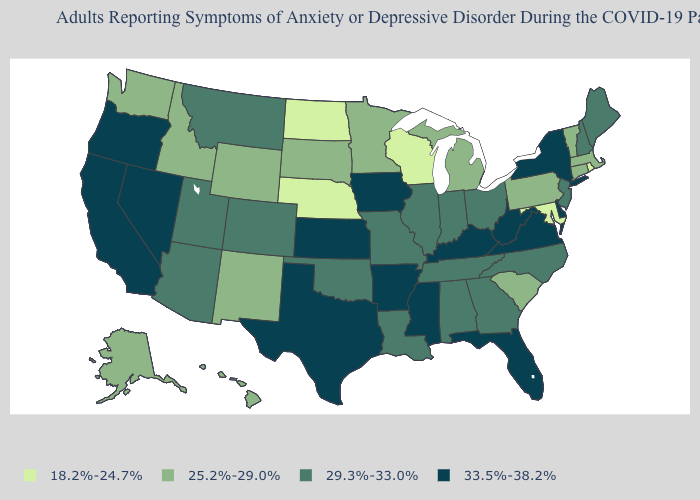What is the lowest value in the USA?
Quick response, please. 18.2%-24.7%. What is the lowest value in the West?
Be succinct. 25.2%-29.0%. What is the value of Rhode Island?
Write a very short answer. 18.2%-24.7%. What is the value of Massachusetts?
Answer briefly. 25.2%-29.0%. Does Ohio have the highest value in the USA?
Write a very short answer. No. Name the states that have a value in the range 29.3%-33.0%?
Concise answer only. Alabama, Arizona, Colorado, Georgia, Illinois, Indiana, Louisiana, Maine, Missouri, Montana, New Hampshire, New Jersey, North Carolina, Ohio, Oklahoma, Tennessee, Utah. Name the states that have a value in the range 29.3%-33.0%?
Keep it brief. Alabama, Arizona, Colorado, Georgia, Illinois, Indiana, Louisiana, Maine, Missouri, Montana, New Hampshire, New Jersey, North Carolina, Ohio, Oklahoma, Tennessee, Utah. What is the value of Kansas?
Keep it brief. 33.5%-38.2%. Among the states that border Oregon , which have the lowest value?
Be succinct. Idaho, Washington. Name the states that have a value in the range 33.5%-38.2%?
Concise answer only. Arkansas, California, Delaware, Florida, Iowa, Kansas, Kentucky, Mississippi, Nevada, New York, Oregon, Texas, Virginia, West Virginia. What is the value of New Jersey?
Be succinct. 29.3%-33.0%. Among the states that border Massachusetts , does Connecticut have the highest value?
Be succinct. No. How many symbols are there in the legend?
Answer briefly. 4. Which states have the lowest value in the Northeast?
Concise answer only. Rhode Island. Among the states that border Georgia , does North Carolina have the highest value?
Concise answer only. No. 